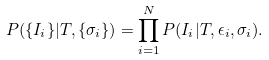Convert formula to latex. <formula><loc_0><loc_0><loc_500><loc_500>P ( \{ I _ { i } \} | T , \{ \sigma _ { i } \} ) = \prod _ { i = 1 } ^ { N } P ( I _ { i } | T , \epsilon _ { i } , \sigma _ { i } ) .</formula> 